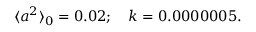Convert formula to latex. <formula><loc_0><loc_0><loc_500><loc_500>\langle a ^ { 2 } \rangle _ { 0 } = 0 . 0 2 ; \quad k = 0 . 0 0 0 0 0 0 5 .</formula> 